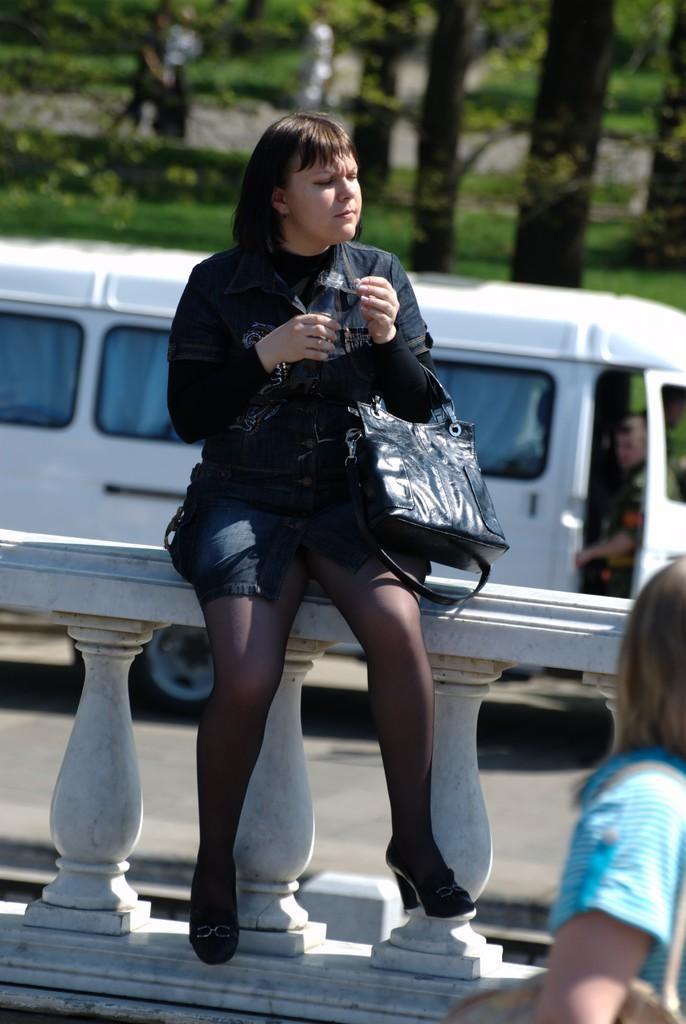Could you give a brief overview of what you see in this image? In the center of the image there is a lady sitting on the railing. To the right side of the image there is a woman. In the background of the image there are trees. There is a van on the road. 